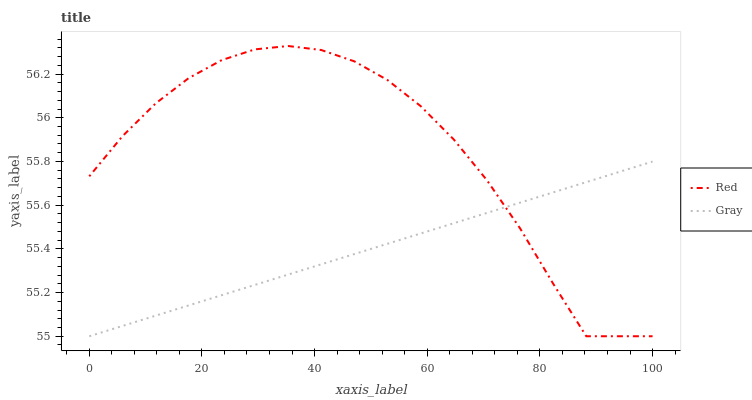Does Gray have the minimum area under the curve?
Answer yes or no. Yes. Does Red have the maximum area under the curve?
Answer yes or no. Yes. Does Red have the minimum area under the curve?
Answer yes or no. No. Is Gray the smoothest?
Answer yes or no. Yes. Is Red the roughest?
Answer yes or no. Yes. Is Red the smoothest?
Answer yes or no. No. Does Gray have the lowest value?
Answer yes or no. Yes. Does Red have the highest value?
Answer yes or no. Yes. Does Gray intersect Red?
Answer yes or no. Yes. Is Gray less than Red?
Answer yes or no. No. Is Gray greater than Red?
Answer yes or no. No. 